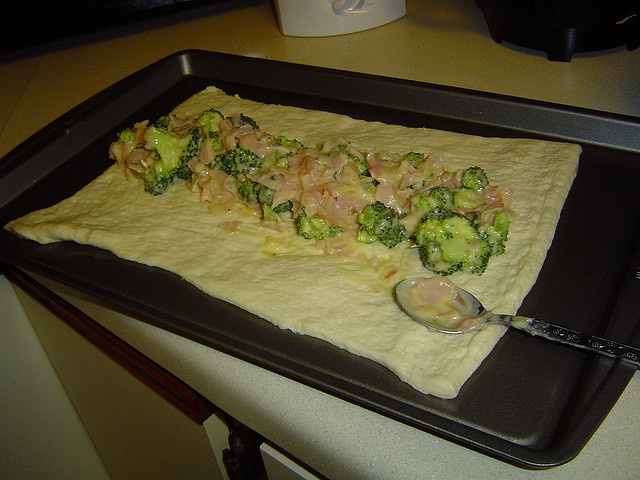Describe the objects in this image and their specific colors. I can see spoon in black, olive, and gray tones, broccoli in black and olive tones, broccoli in black and olive tones, broccoli in black and olive tones, and broccoli in black, olive, and darkgreen tones in this image. 